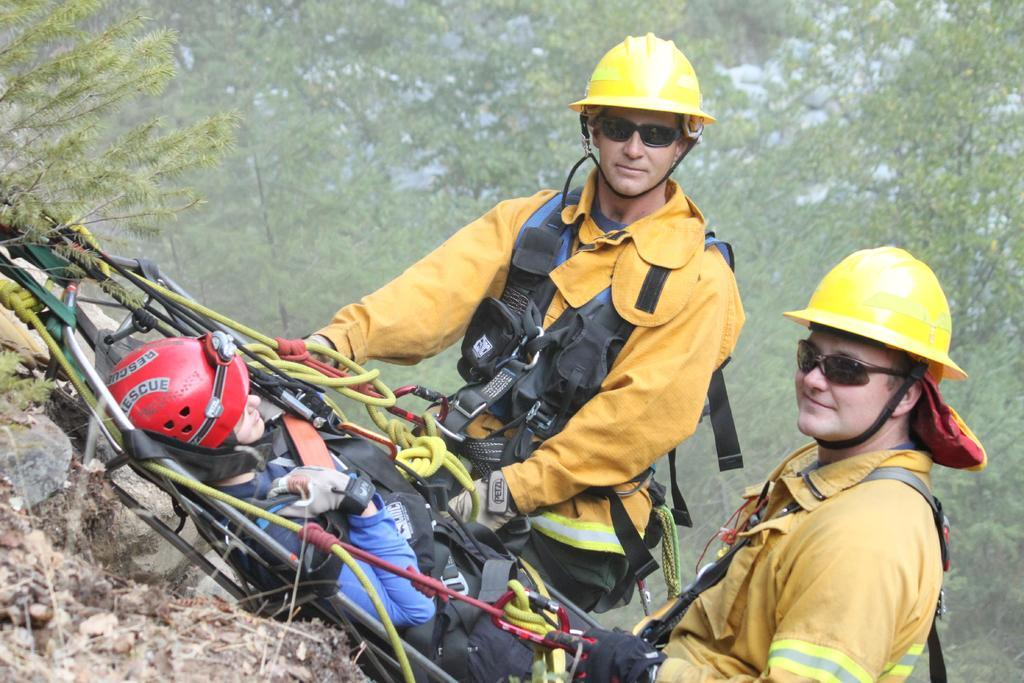Who or what can be seen in the image? There are people in the image. What are the people doing in the image? The people are climbing a hill. How are the people assisting themselves while climbing the hill? The people are using a rope for assistance. What type of natural environment is visible in the image? There are trees visible in the image. Where is the house located in the image? There is no house present in the image. Can you see a dock in the image? There is no dock present in the image. 